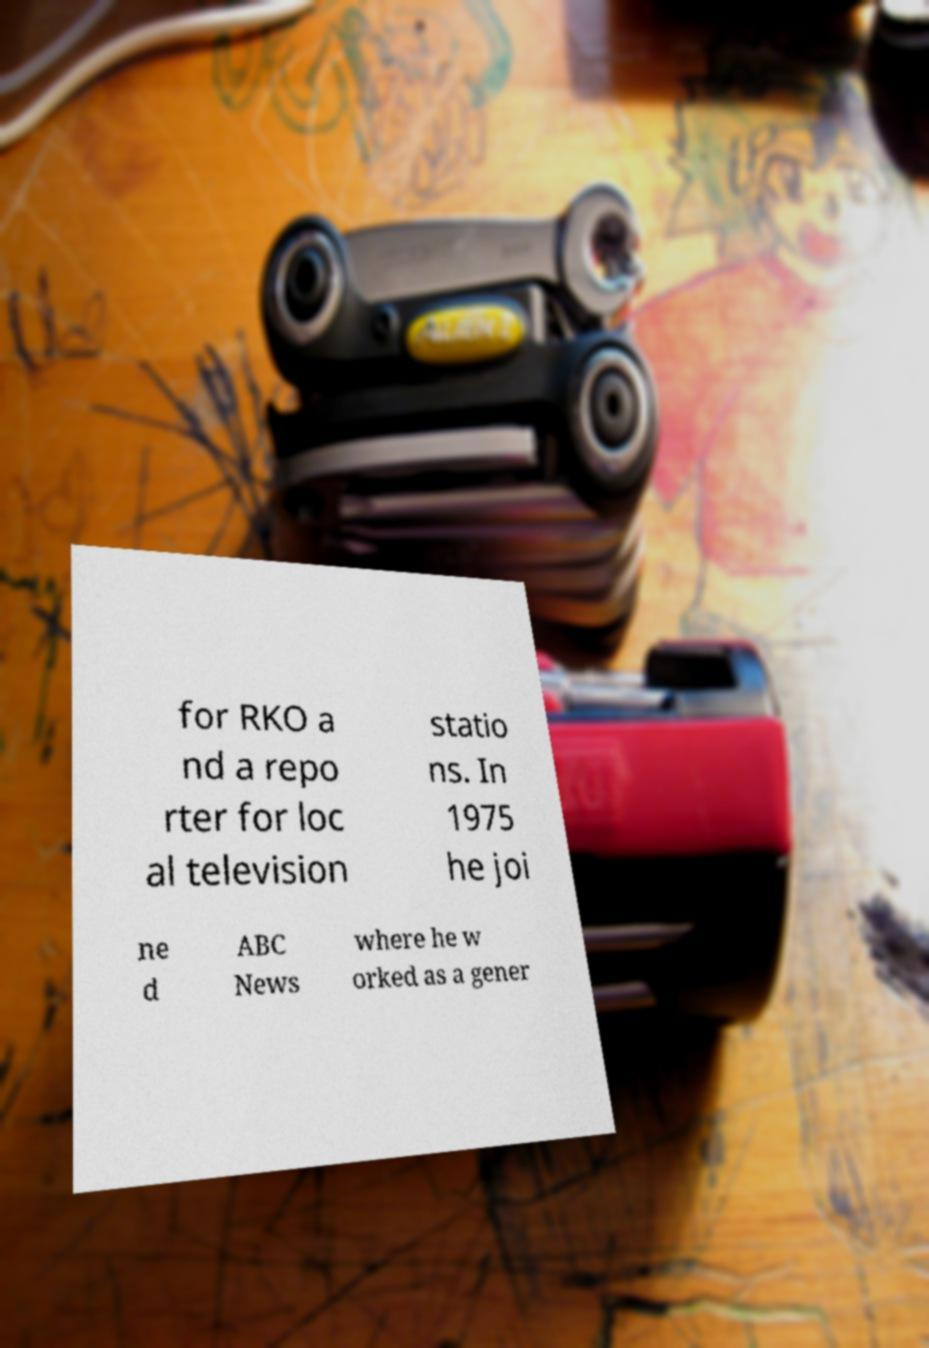Please identify and transcribe the text found in this image. for RKO a nd a repo rter for loc al television statio ns. In 1975 he joi ne d ABC News where he w orked as a gener 